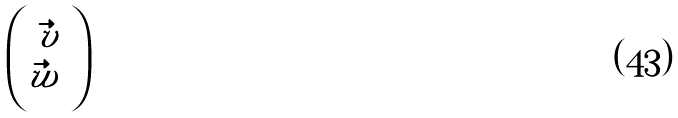<formula> <loc_0><loc_0><loc_500><loc_500>\begin{pmatrix} \vec { v } \\ \vec { w } \ \end{pmatrix}</formula> 